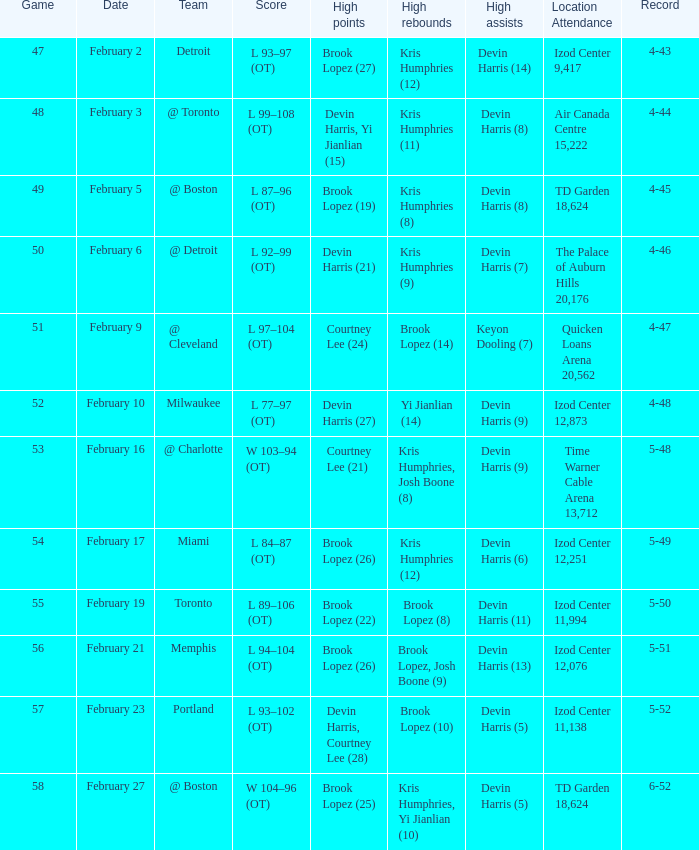Who did the high assists in the game played on February 9? Keyon Dooling (7). 